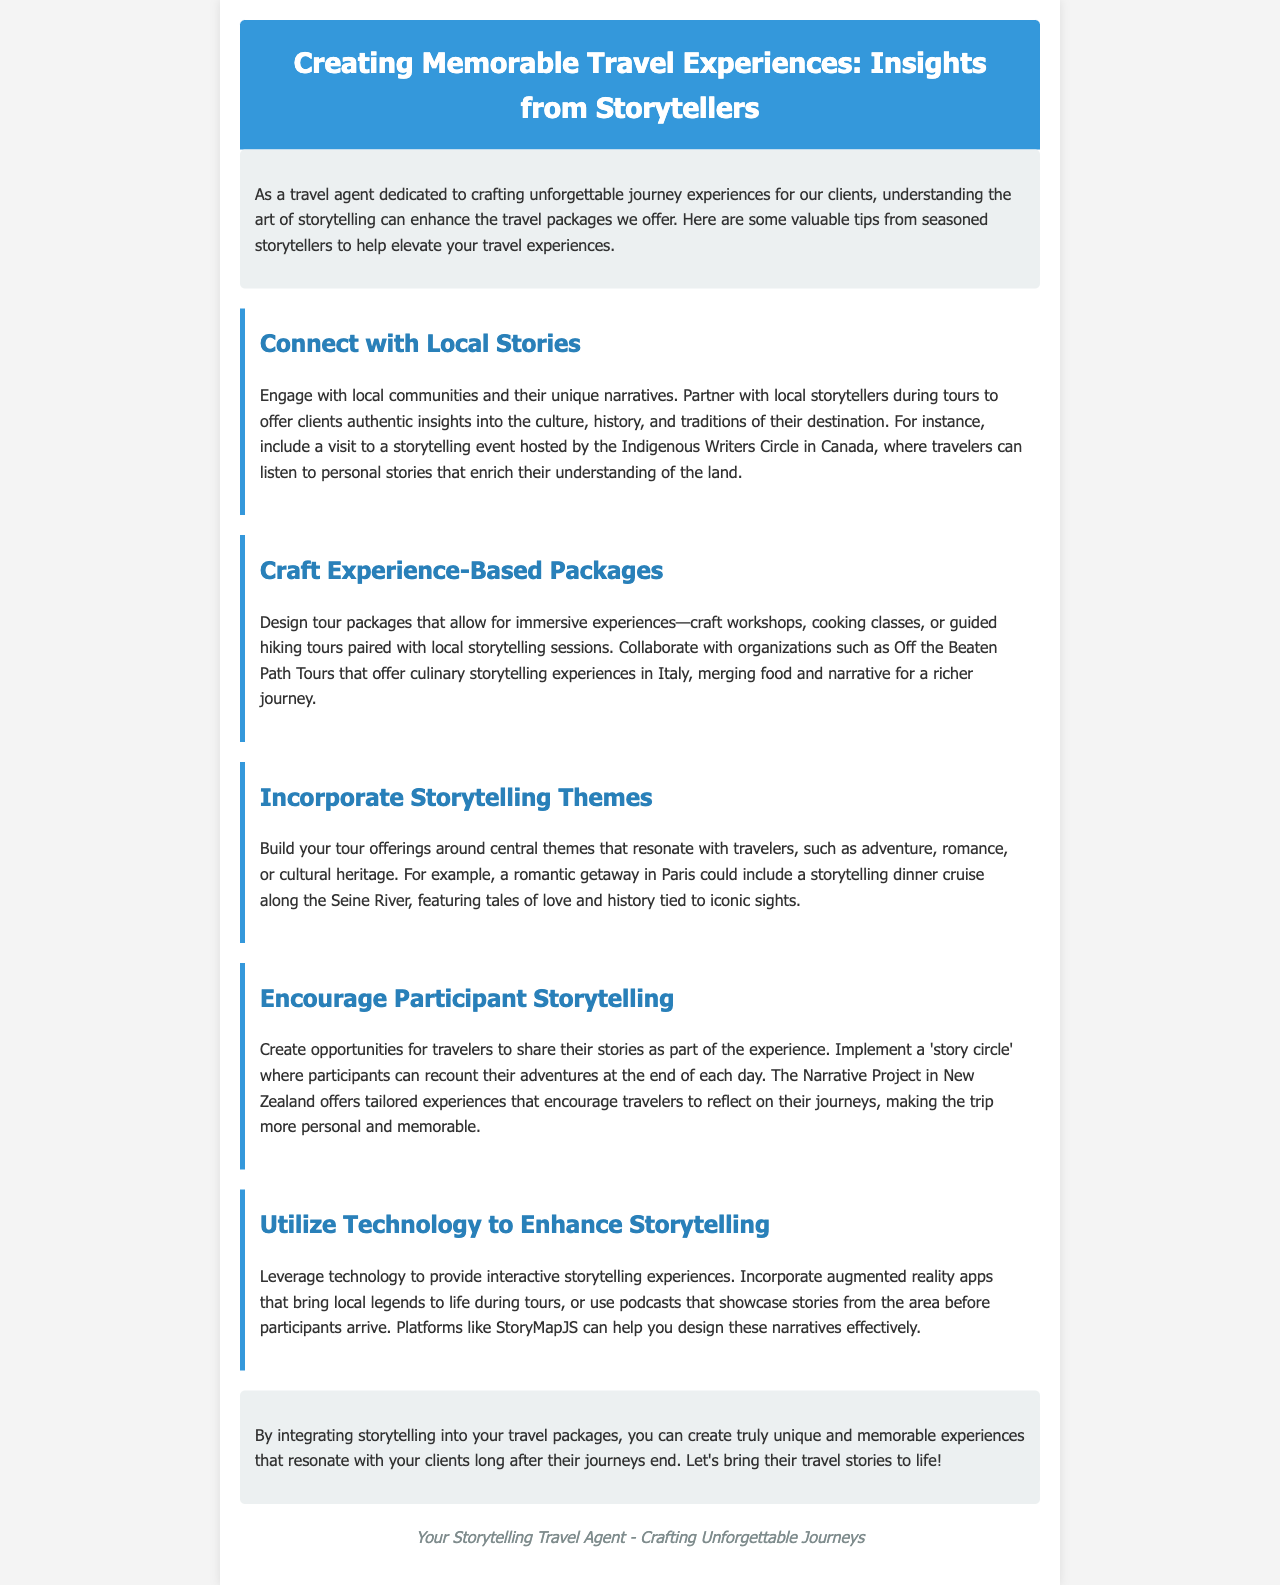what is the title of the document? The title is prominently displayed at the top of the document, indicating the main topic.
Answer: Creating Memorable Travel Experiences: Insights from Storytellers who is the author of the document? The footer section contains information about the author, which is stated clearly.
Answer: Your Storytelling Travel Agent what theme is suggested for a romantic getaway in Paris? The document discusses a specific theme for a romantic getaway that includes storytelling.
Answer: storytelling dinner cruise name a partner organization mentioned for culinary storytelling experiences. The document lists an organization that offers unique culinary experiences.
Answer: Off the Beaten Path Tours what type of technology is suggested to enhance storytelling? The document mentions technology that can improve the storytelling experience during tours.
Answer: augmented reality apps how many tips are provided in the newsletter? Counting the tip sections reveals the total number of unique suggestions offered.
Answer: Five tips what is the purpose of incorporating storytelling according to the document? The introduction explains the main benefit of integrating storytelling into travel experiences.
Answer: create truly unique and memorable experiences what is a suggested activity for participant storytelling? The document recommends a specific way for travelers to share their experiences during the trip.
Answer: story circle 